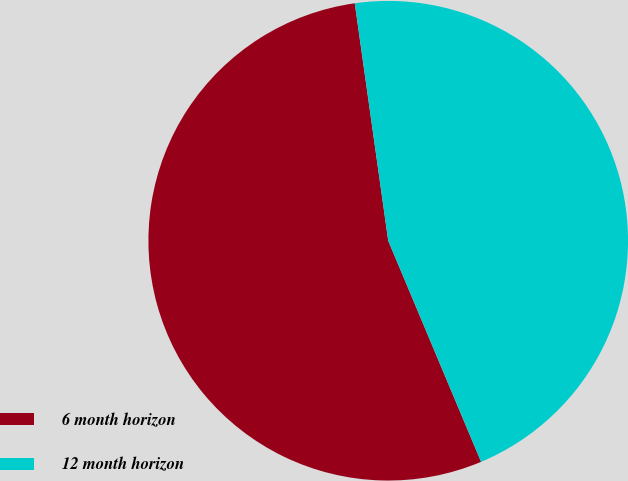Convert chart to OTSL. <chart><loc_0><loc_0><loc_500><loc_500><pie_chart><fcel>6 month horizon<fcel>12 month horizon<nl><fcel>54.1%<fcel>45.9%<nl></chart> 